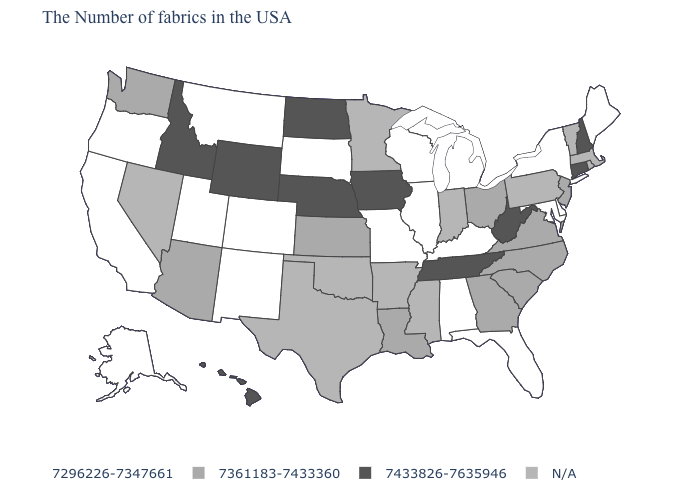Among the states that border Missouri , which have the lowest value?
Write a very short answer. Kentucky, Illinois. What is the highest value in states that border Massachusetts?
Write a very short answer. 7433826-7635946. What is the value of Illinois?
Be succinct. 7296226-7347661. What is the value of Maine?
Short answer required. 7296226-7347661. Name the states that have a value in the range 7296226-7347661?
Concise answer only. Maine, New York, Delaware, Maryland, Florida, Michigan, Kentucky, Alabama, Wisconsin, Illinois, Missouri, South Dakota, Colorado, New Mexico, Utah, Montana, California, Oregon, Alaska. Name the states that have a value in the range N/A?
Give a very brief answer. Massachusetts, Rhode Island, Vermont, Pennsylvania, Indiana, Mississippi, Arkansas, Minnesota, Oklahoma, Texas, Nevada. Which states hav the highest value in the West?
Keep it brief. Wyoming, Idaho, Hawaii. Name the states that have a value in the range N/A?
Give a very brief answer. Massachusetts, Rhode Island, Vermont, Pennsylvania, Indiana, Mississippi, Arkansas, Minnesota, Oklahoma, Texas, Nevada. Does Wyoming have the highest value in the West?
Write a very short answer. Yes. What is the value of Connecticut?
Keep it brief. 7433826-7635946. Which states have the lowest value in the West?
Short answer required. Colorado, New Mexico, Utah, Montana, California, Oregon, Alaska. What is the value of Washington?
Give a very brief answer. 7361183-7433360. Does Connecticut have the highest value in the USA?
Keep it brief. Yes. Is the legend a continuous bar?
Be succinct. No. Does Washington have the lowest value in the West?
Give a very brief answer. No. 